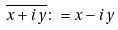<formula> <loc_0><loc_0><loc_500><loc_500>\overline { x + i y } \colon = x - i y</formula> 